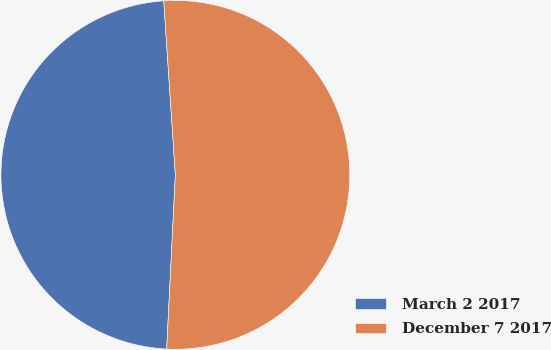<chart> <loc_0><loc_0><loc_500><loc_500><pie_chart><fcel>March 2 2017<fcel>December 7 2017<nl><fcel>48.15%<fcel>51.85%<nl></chart> 